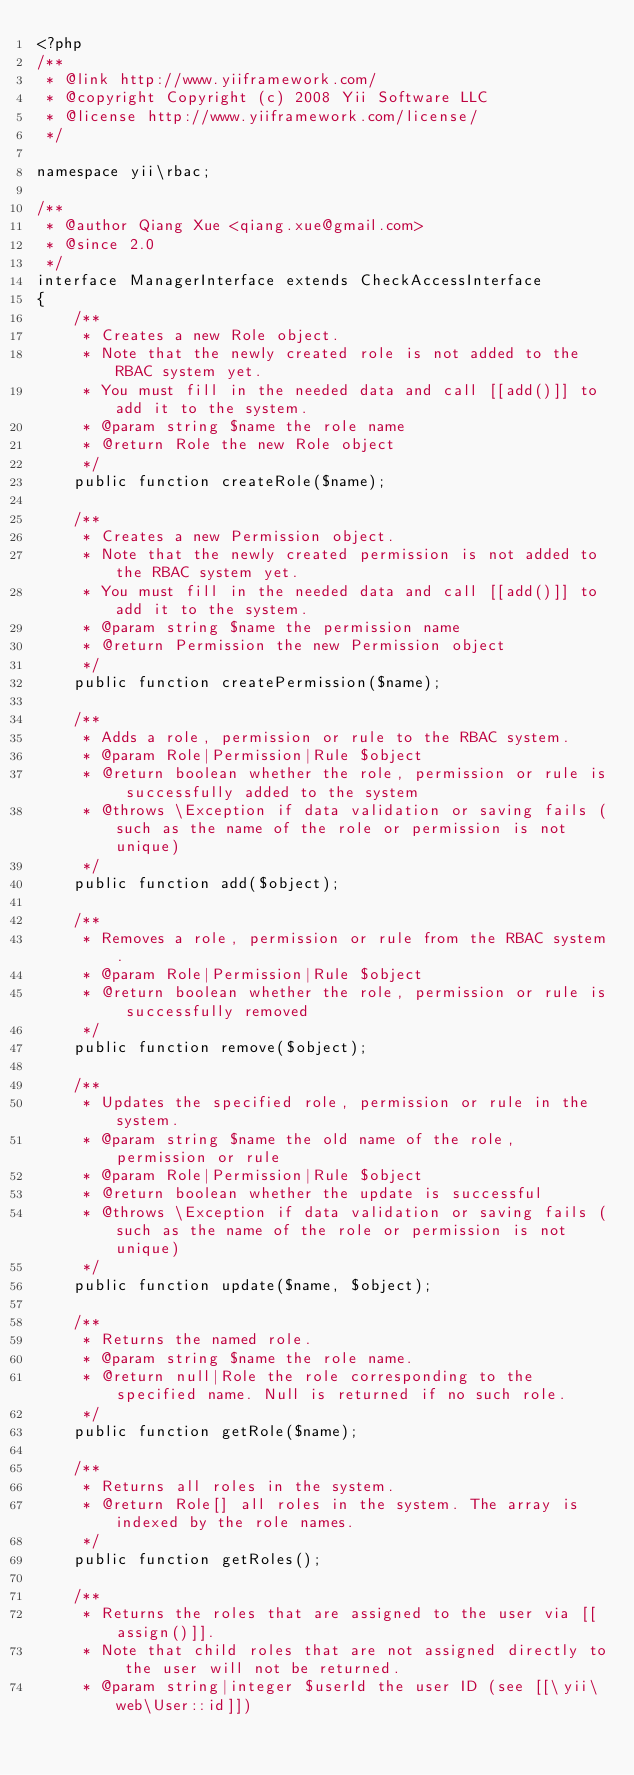<code> <loc_0><loc_0><loc_500><loc_500><_PHP_><?php
/**
 * @link http://www.yiiframework.com/
 * @copyright Copyright (c) 2008 Yii Software LLC
 * @license http://www.yiiframework.com/license/
 */

namespace yii\rbac;

/**
 * @author Qiang Xue <qiang.xue@gmail.com>
 * @since 2.0
 */
interface ManagerInterface extends CheckAccessInterface
{
    /**
     * Creates a new Role object.
     * Note that the newly created role is not added to the RBAC system yet.
     * You must fill in the needed data and call [[add()]] to add it to the system.
     * @param string $name the role name
     * @return Role the new Role object
     */
    public function createRole($name);

    /**
     * Creates a new Permission object.
     * Note that the newly created permission is not added to the RBAC system yet.
     * You must fill in the needed data and call [[add()]] to add it to the system.
     * @param string $name the permission name
     * @return Permission the new Permission object
     */
    public function createPermission($name);

    /**
     * Adds a role, permission or rule to the RBAC system.
     * @param Role|Permission|Rule $object
     * @return boolean whether the role, permission or rule is successfully added to the system
     * @throws \Exception if data validation or saving fails (such as the name of the role or permission is not unique)
     */
    public function add($object);

    /**
     * Removes a role, permission or rule from the RBAC system.
     * @param Role|Permission|Rule $object
     * @return boolean whether the role, permission or rule is successfully removed
     */
    public function remove($object);

    /**
     * Updates the specified role, permission or rule in the system.
     * @param string $name the old name of the role, permission or rule
     * @param Role|Permission|Rule $object
     * @return boolean whether the update is successful
     * @throws \Exception if data validation or saving fails (such as the name of the role or permission is not unique)
     */
    public function update($name, $object);

    /**
     * Returns the named role.
     * @param string $name the role name.
     * @return null|Role the role corresponding to the specified name. Null is returned if no such role.
     */
    public function getRole($name);

    /**
     * Returns all roles in the system.
     * @return Role[] all roles in the system. The array is indexed by the role names.
     */
    public function getRoles();

    /**
     * Returns the roles that are assigned to the user via [[assign()]].
     * Note that child roles that are not assigned directly to the user will not be returned.
     * @param string|integer $userId the user ID (see [[\yii\web\User::id]])</code> 